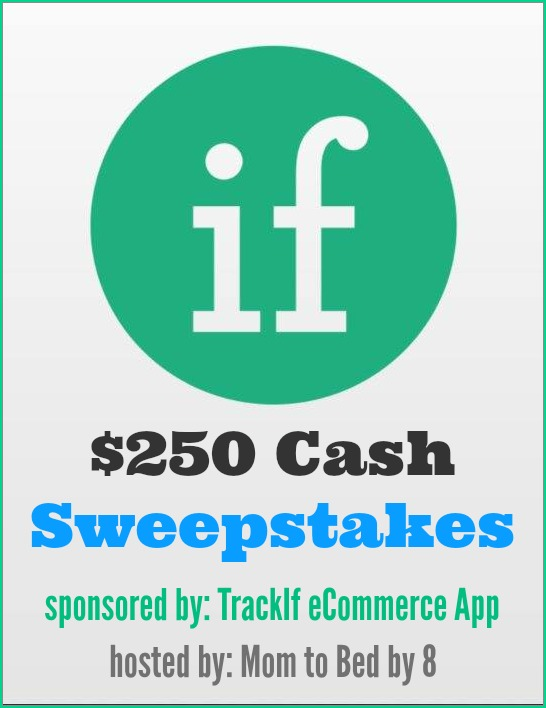Why do you think TrackIf eCommerce App chose 'Mom to Bed by 8' to host their $250 Cash Sweepstakes? TrackIf eCommerce App likely chose 'Mom to Bed by 8' as the host for their $250 Cash Sweepstakes because the blog has a dedicated following of parents and families who may be actively involved in making online purchases. By partnering with a platform that has a relevant and engaged audience, TrackIf can more effectively promote its app to potential users who can benefit from its eCommerce tracking features. What are the potential long-term benefits for 'Mom to Bed by 8' in hosting this sweepstakes? In the long term, 'Mom to Bed by 8' can gain several benefits from hosting the $250 Cash Sweepstakes sponsored by TrackIf eCommerce App. Firstly, the blog can increase its audience engagement by offering attractive content, which helps in building and retaining a loyal readership. Additionally, the blog's association with a reputed sponsor can enhance its credibility and attract more high-quality partnerships in the future. The sweepstakes also provides an excellent opportunity for the blog to collect valuable data on its readers through entry registrations, which can be used to tailor content more effectively and enhance user experience. 